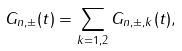<formula> <loc_0><loc_0><loc_500><loc_500>G _ { n , \pm } ( t ) = \sum _ { k = 1 , 2 } G _ { n , \pm , k } ( t ) ,</formula> 